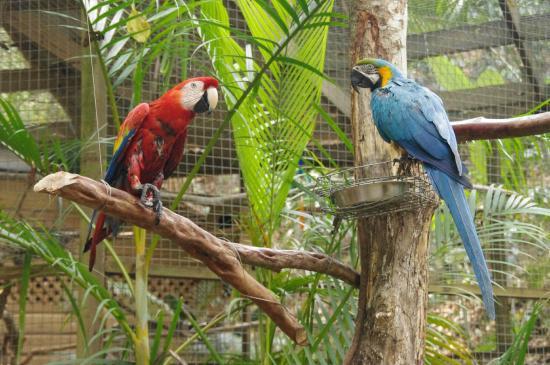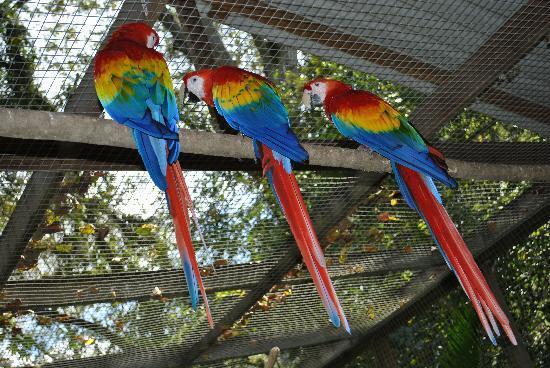The first image is the image on the left, the second image is the image on the right. Analyze the images presented: Is the assertion "The image on the right contains only one parrot." valid? Answer yes or no. No. The first image is the image on the left, the second image is the image on the right. For the images displayed, is the sentence "One of the images contains parrots of different colors." factually correct? Answer yes or no. Yes. 